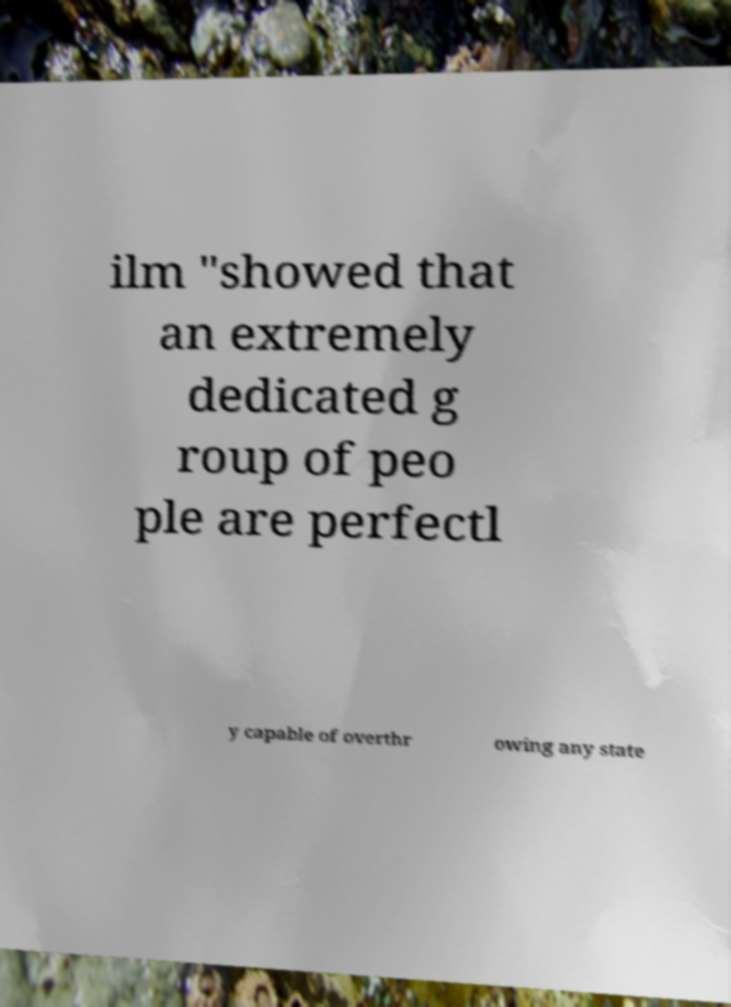Could you extract and type out the text from this image? ilm "showed that an extremely dedicated g roup of peo ple are perfectl y capable of overthr owing any state 